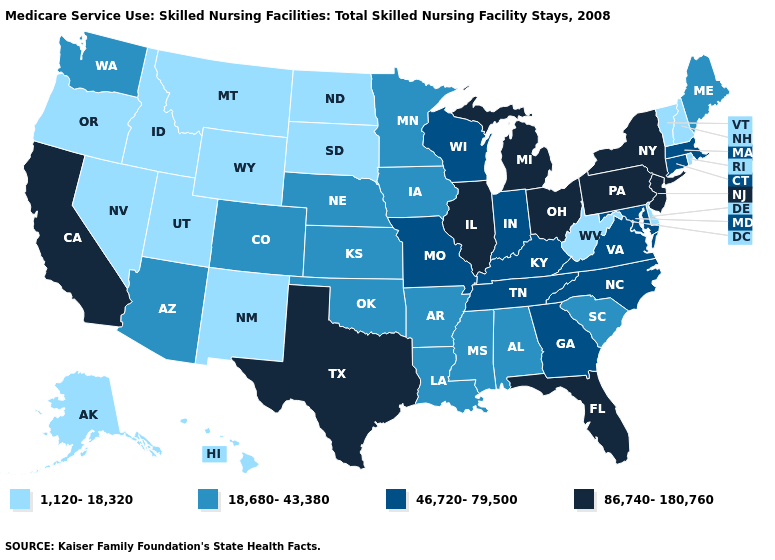What is the lowest value in the USA?
Give a very brief answer. 1,120-18,320. Name the states that have a value in the range 86,740-180,760?
Short answer required. California, Florida, Illinois, Michigan, New Jersey, New York, Ohio, Pennsylvania, Texas. Name the states that have a value in the range 18,680-43,380?
Be succinct. Alabama, Arizona, Arkansas, Colorado, Iowa, Kansas, Louisiana, Maine, Minnesota, Mississippi, Nebraska, Oklahoma, South Carolina, Washington. Which states hav the highest value in the South?
Short answer required. Florida, Texas. Name the states that have a value in the range 46,720-79,500?
Give a very brief answer. Connecticut, Georgia, Indiana, Kentucky, Maryland, Massachusetts, Missouri, North Carolina, Tennessee, Virginia, Wisconsin. Does the first symbol in the legend represent the smallest category?
Give a very brief answer. Yes. Which states have the lowest value in the USA?
Short answer required. Alaska, Delaware, Hawaii, Idaho, Montana, Nevada, New Hampshire, New Mexico, North Dakota, Oregon, Rhode Island, South Dakota, Utah, Vermont, West Virginia, Wyoming. Does Iowa have the same value as Georgia?
Be succinct. No. Does Maine have the lowest value in the Northeast?
Give a very brief answer. No. Does California have the highest value in the West?
Quick response, please. Yes. How many symbols are there in the legend?
Be succinct. 4. Is the legend a continuous bar?
Quick response, please. No. Does Washington have the lowest value in the USA?
Quick response, please. No. Does Kentucky have the same value as Maryland?
Give a very brief answer. Yes. Among the states that border Kansas , which have the lowest value?
Keep it brief. Colorado, Nebraska, Oklahoma. 